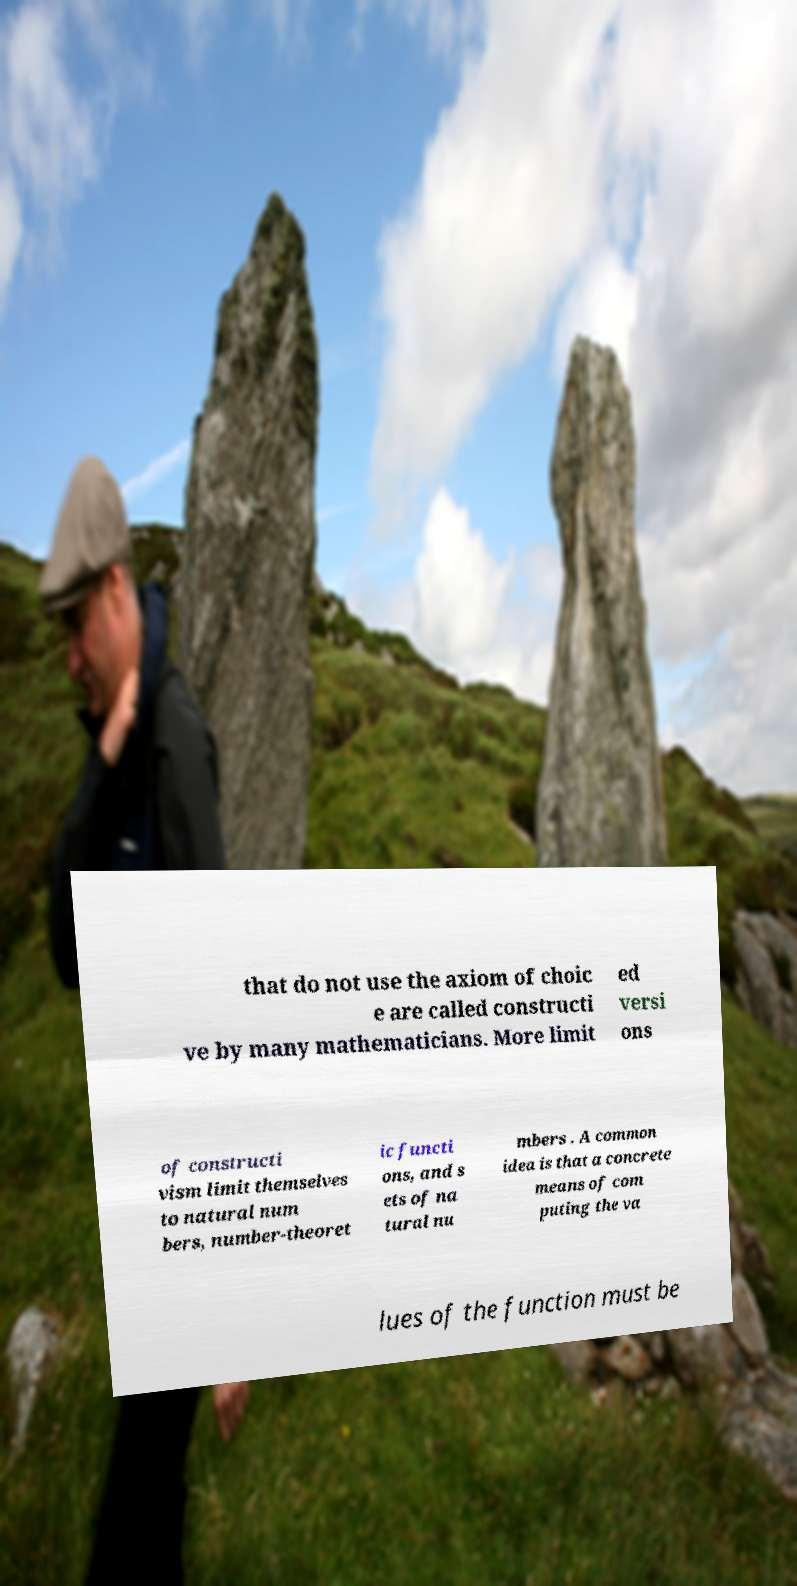For documentation purposes, I need the text within this image transcribed. Could you provide that? that do not use the axiom of choic e are called constructi ve by many mathematicians. More limit ed versi ons of constructi vism limit themselves to natural num bers, number-theoret ic functi ons, and s ets of na tural nu mbers . A common idea is that a concrete means of com puting the va lues of the function must be 